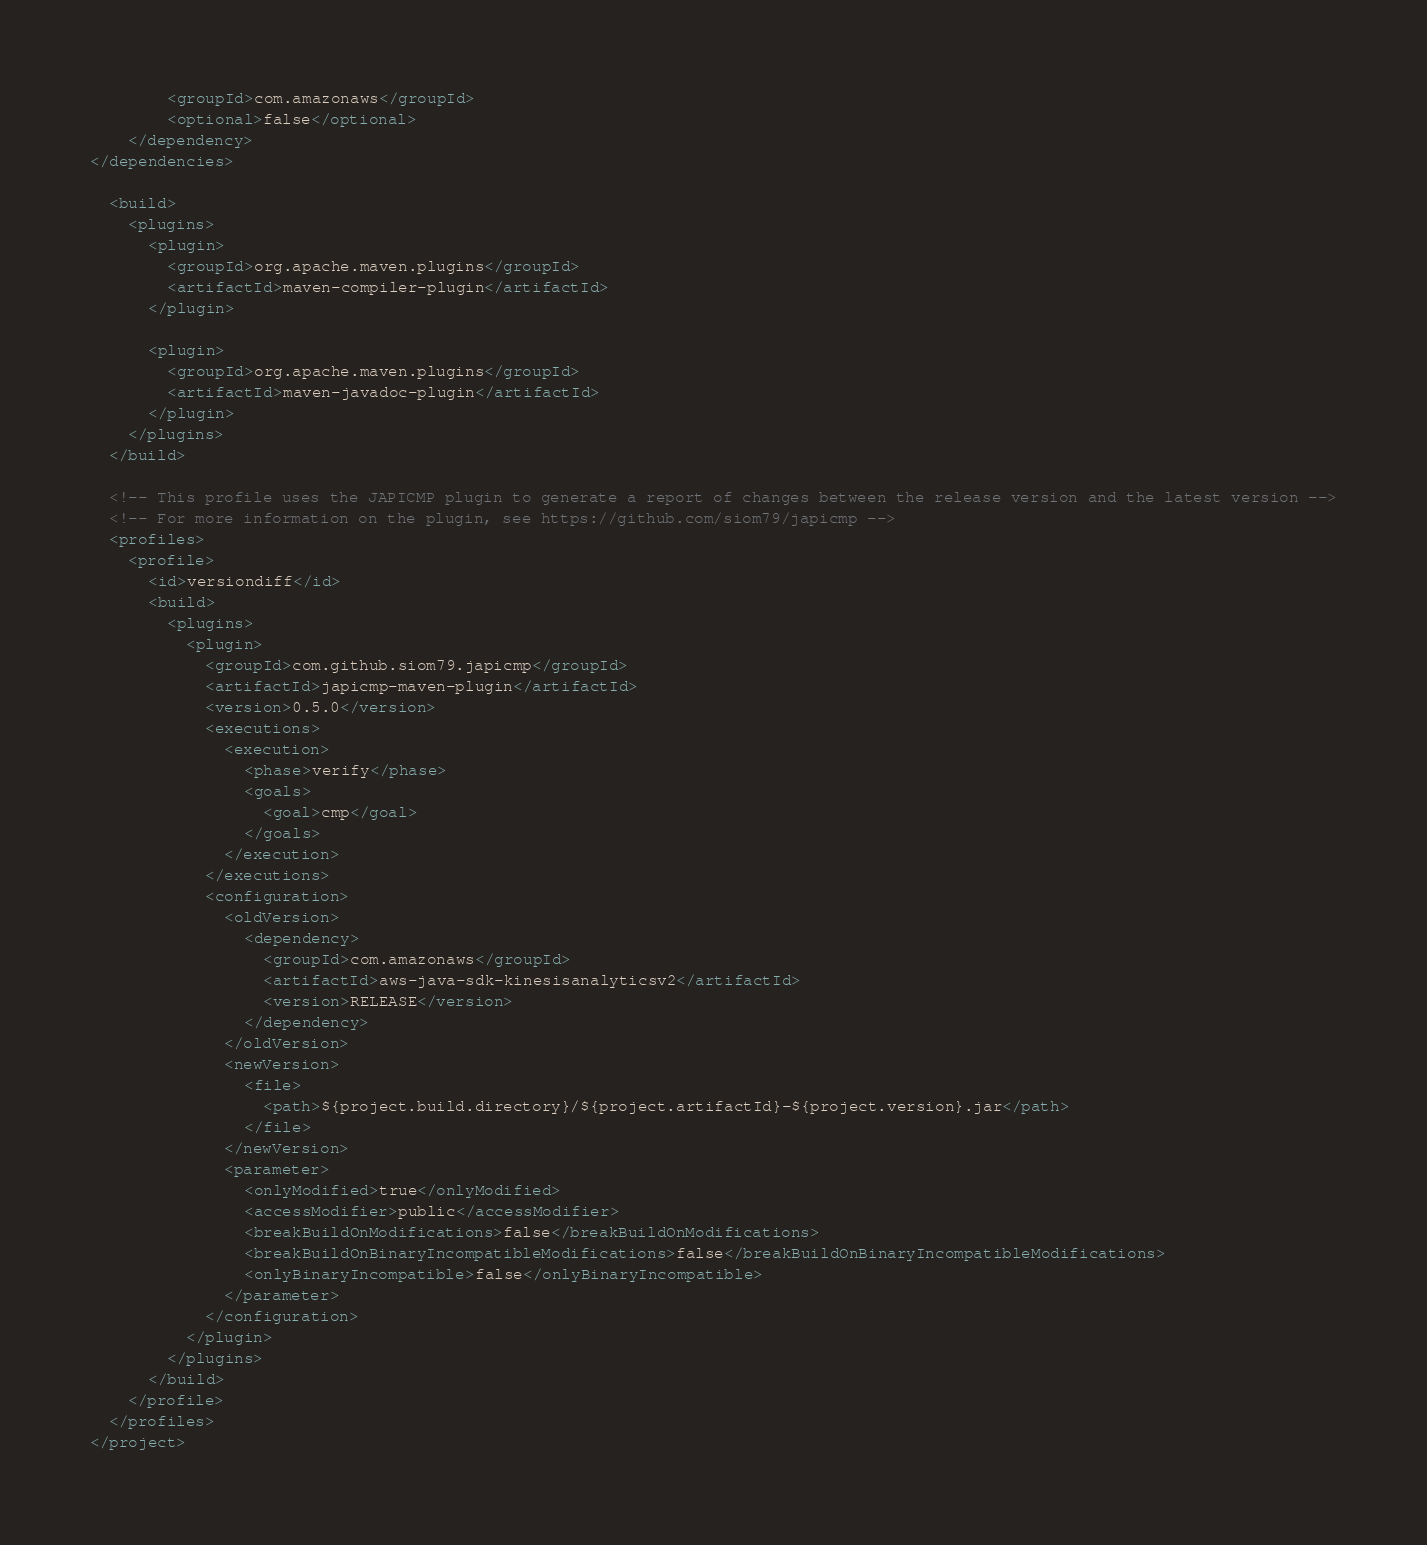Convert code to text. <code><loc_0><loc_0><loc_500><loc_500><_XML_>        <groupId>com.amazonaws</groupId>
        <optional>false</optional>
    </dependency>
</dependencies>

  <build>
    <plugins>
      <plugin>
        <groupId>org.apache.maven.plugins</groupId>
        <artifactId>maven-compiler-plugin</artifactId>
      </plugin>

      <plugin>
        <groupId>org.apache.maven.plugins</groupId>
        <artifactId>maven-javadoc-plugin</artifactId>
      </plugin>
    </plugins>
  </build>

  <!-- This profile uses the JAPICMP plugin to generate a report of changes between the release version and the latest version -->
  <!-- For more information on the plugin, see https://github.com/siom79/japicmp -->
  <profiles>
    <profile>
      <id>versiondiff</id>
      <build>
        <plugins>
          <plugin>
            <groupId>com.github.siom79.japicmp</groupId>
            <artifactId>japicmp-maven-plugin</artifactId>
            <version>0.5.0</version>
            <executions>
              <execution>
                <phase>verify</phase>
                <goals>
                  <goal>cmp</goal>
                </goals>
              </execution>
            </executions>
            <configuration>
              <oldVersion>
                <dependency>
                  <groupId>com.amazonaws</groupId>
                  <artifactId>aws-java-sdk-kinesisanalyticsv2</artifactId>
                  <version>RELEASE</version>
                </dependency>
              </oldVersion>
              <newVersion>
                <file>
                  <path>${project.build.directory}/${project.artifactId}-${project.version}.jar</path>
                </file>
              </newVersion>
              <parameter>
                <onlyModified>true</onlyModified>
                <accessModifier>public</accessModifier>
                <breakBuildOnModifications>false</breakBuildOnModifications>
                <breakBuildOnBinaryIncompatibleModifications>false</breakBuildOnBinaryIncompatibleModifications>
                <onlyBinaryIncompatible>false</onlyBinaryIncompatible>
              </parameter>
            </configuration>
          </plugin>
        </plugins>
      </build>
    </profile>
  </profiles>
</project>
</code> 